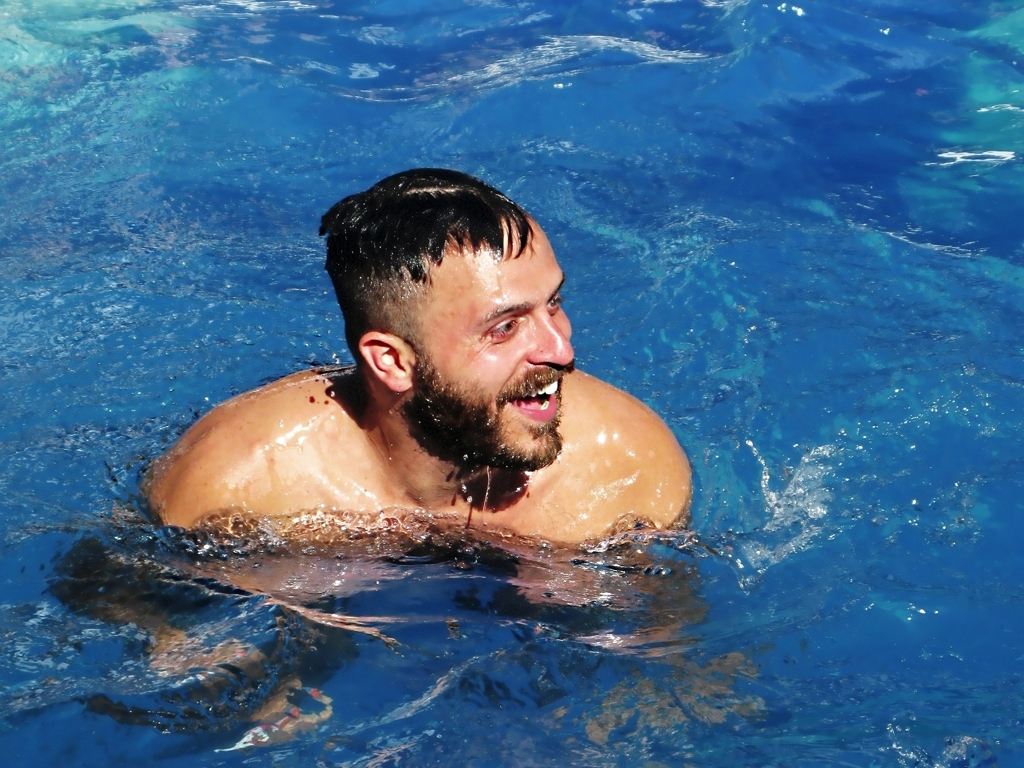Can you describe the water in this image? Certainly! The water in the image looks clear with varying shades of blue, suggesting purity and possibly a chemically maintained pool. The surface of the water is disturbed around the man, reflecting his movements, and creating dynamic ripples that indicate his active engagement with the environment. 